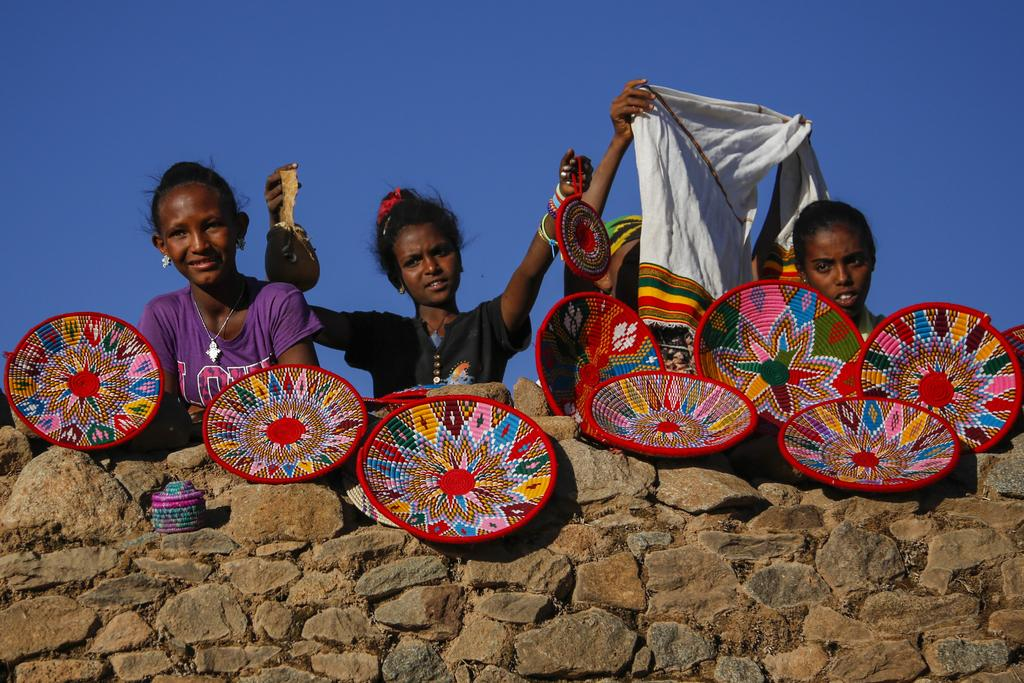How many people are in the image? There are four persons in the image. What type of material is visible in the image? There is cloth visible in the image. What else can be seen in the image besides the people and cloth? There are objects in the image. What type of natural feature is present in the image? There is a rock wall in the image. What is visible in the background of the image? The sky is visible in the background of the image. What type of test is being conducted in the image? There is no test being conducted in the image; it features four persons, cloth, objects, a rock wall, and the sky. How many pies are visible on the rock wall in the image? There are no pies visible on the rock wall in the image; only the rock wall itself is present. 